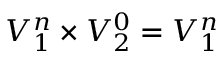<formula> <loc_0><loc_0><loc_500><loc_500>V _ { 1 } ^ { n } \times V _ { 2 } ^ { 0 } = V _ { 1 } ^ { n }</formula> 